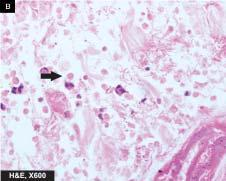re papillae seen at the margin of ulcer?
Answer the question using a single word or phrase. No 